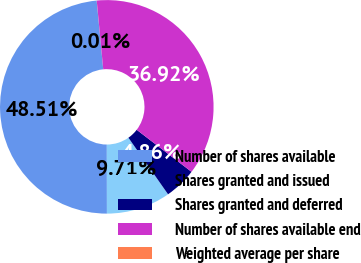<chart> <loc_0><loc_0><loc_500><loc_500><pie_chart><fcel>Number of shares available<fcel>Shares granted and issued<fcel>Shares granted and deferred<fcel>Number of shares available end<fcel>Weighted average per share<nl><fcel>48.51%<fcel>9.71%<fcel>4.86%<fcel>36.92%<fcel>0.01%<nl></chart> 